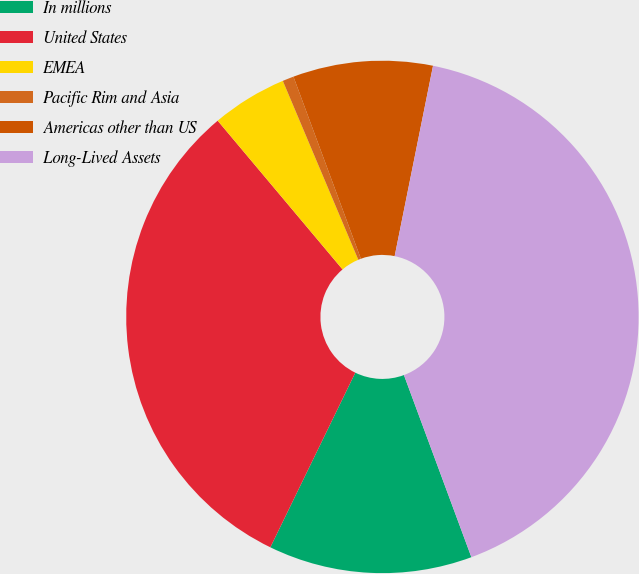Convert chart to OTSL. <chart><loc_0><loc_0><loc_500><loc_500><pie_chart><fcel>In millions<fcel>United States<fcel>EMEA<fcel>Pacific Rim and Asia<fcel>Americas other than US<fcel>Long-Lived Assets<nl><fcel>12.85%<fcel>31.68%<fcel>4.76%<fcel>0.71%<fcel>8.81%<fcel>41.19%<nl></chart> 